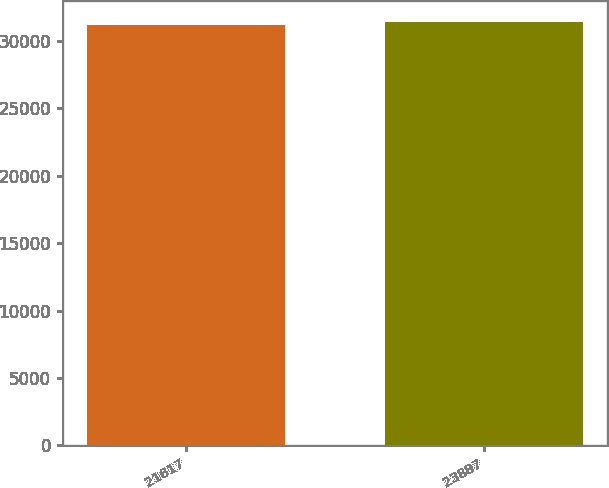<chart> <loc_0><loc_0><loc_500><loc_500><bar_chart><fcel>21617<fcel>23887<nl><fcel>31170<fcel>31409<nl></chart> 